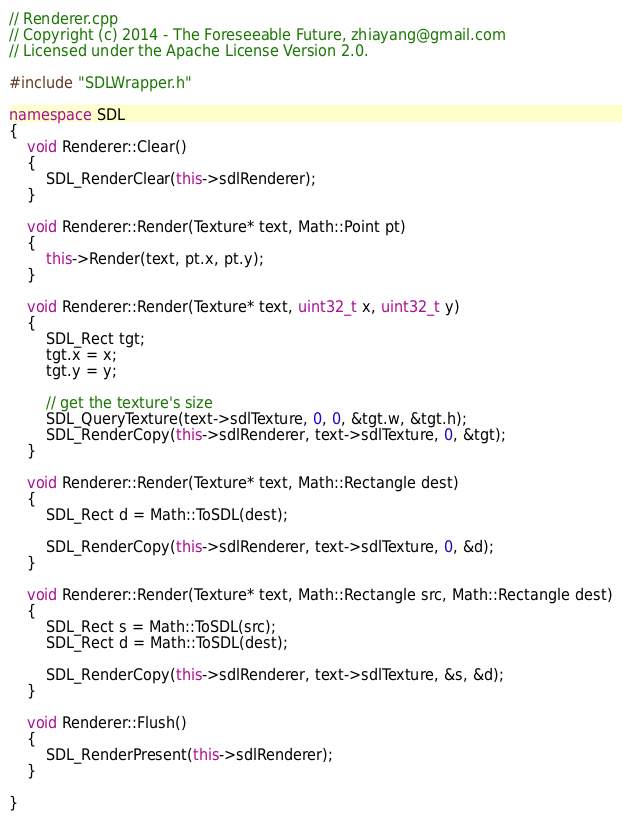<code> <loc_0><loc_0><loc_500><loc_500><_C++_>// Renderer.cpp
// Copyright (c) 2014 - The Foreseeable Future, zhiayang@gmail.com
// Licensed under the Apache License Version 2.0.

#include "SDLWrapper.h"

namespace SDL
{
	void Renderer::Clear()
	{
		SDL_RenderClear(this->sdlRenderer);
	}

	void Renderer::Render(Texture* text, Math::Point pt)
	{
		this->Render(text, pt.x, pt.y);
	}

	void Renderer::Render(Texture* text, uint32_t x, uint32_t y)
	{
		SDL_Rect tgt;
		tgt.x = x;
		tgt.y = y;

		// get the texture's size
		SDL_QueryTexture(text->sdlTexture, 0, 0, &tgt.w, &tgt.h);
		SDL_RenderCopy(this->sdlRenderer, text->sdlTexture, 0, &tgt);
	}

	void Renderer::Render(Texture* text, Math::Rectangle dest)
	{
		SDL_Rect d = Math::ToSDL(dest);

		SDL_RenderCopy(this->sdlRenderer, text->sdlTexture, 0, &d);
	}

	void Renderer::Render(Texture* text, Math::Rectangle src, Math::Rectangle dest)
	{
		SDL_Rect s = Math::ToSDL(src);
		SDL_Rect d = Math::ToSDL(dest);

		SDL_RenderCopy(this->sdlRenderer, text->sdlTexture, &s, &d);
	}

	void Renderer::Flush()
	{
		SDL_RenderPresent(this->sdlRenderer);
	}

}



</code> 